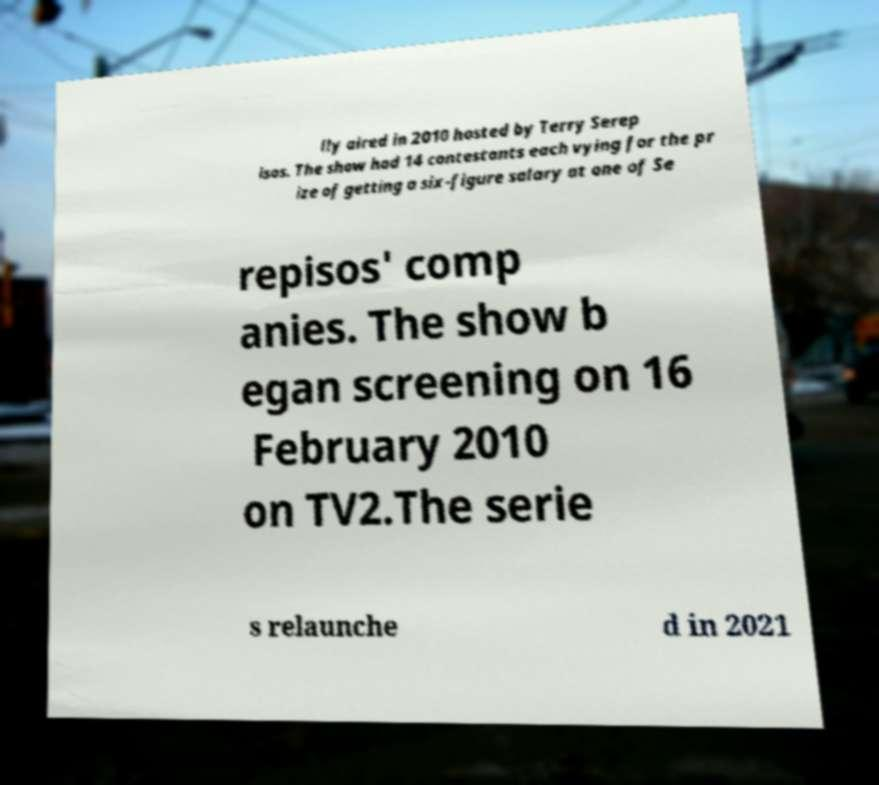I need the written content from this picture converted into text. Can you do that? lly aired in 2010 hosted by Terry Serep isos. The show had 14 contestants each vying for the pr ize of getting a six-figure salary at one of Se repisos' comp anies. The show b egan screening on 16 February 2010 on TV2.The serie s relaunche d in 2021 